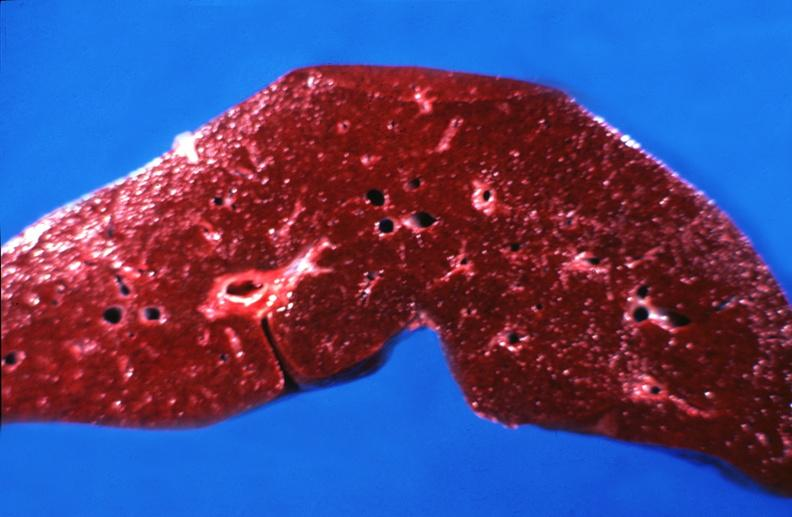s hepatobiliary present?
Answer the question using a single word or phrase. Yes 